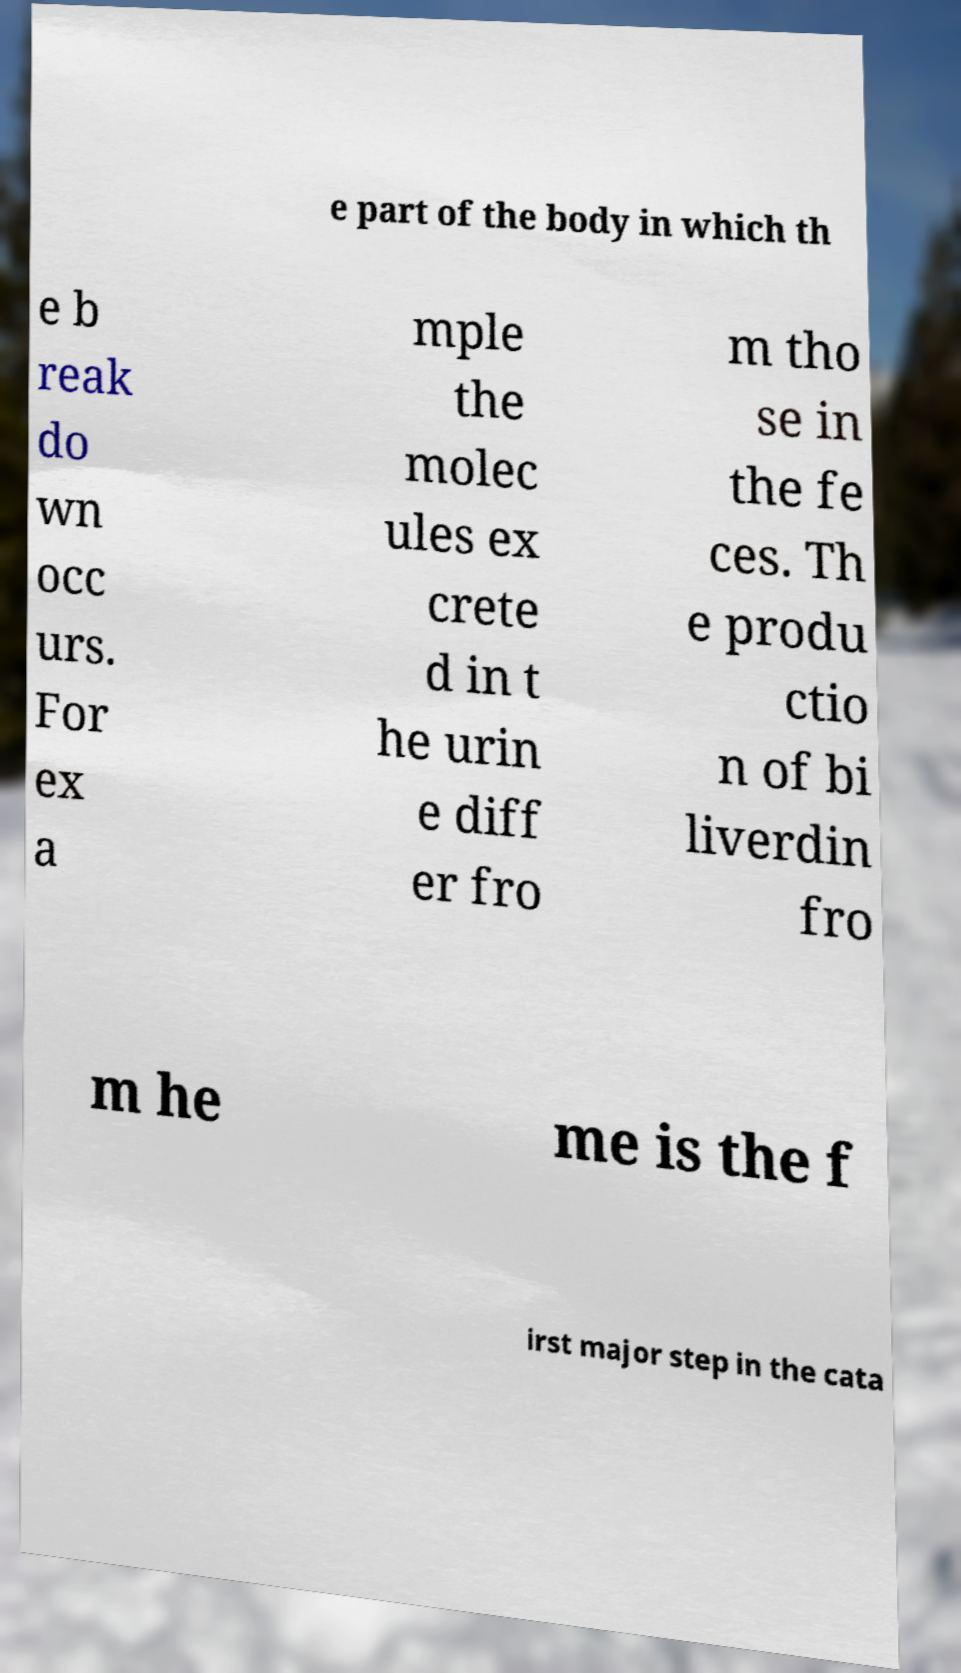Could you extract and type out the text from this image? e part of the body in which th e b reak do wn occ urs. For ex a mple the molec ules ex crete d in t he urin e diff er fro m tho se in the fe ces. Th e produ ctio n of bi liverdin fro m he me is the f irst major step in the cata 